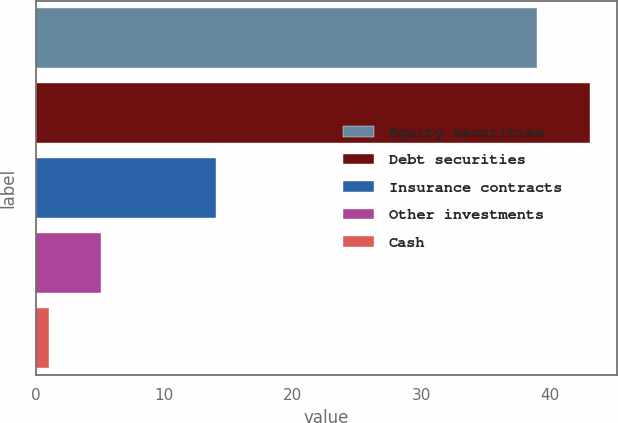Convert chart. <chart><loc_0><loc_0><loc_500><loc_500><bar_chart><fcel>Equity securities<fcel>Debt securities<fcel>Insurance contracts<fcel>Other investments<fcel>Cash<nl><fcel>39<fcel>43.1<fcel>14<fcel>5.1<fcel>1<nl></chart> 